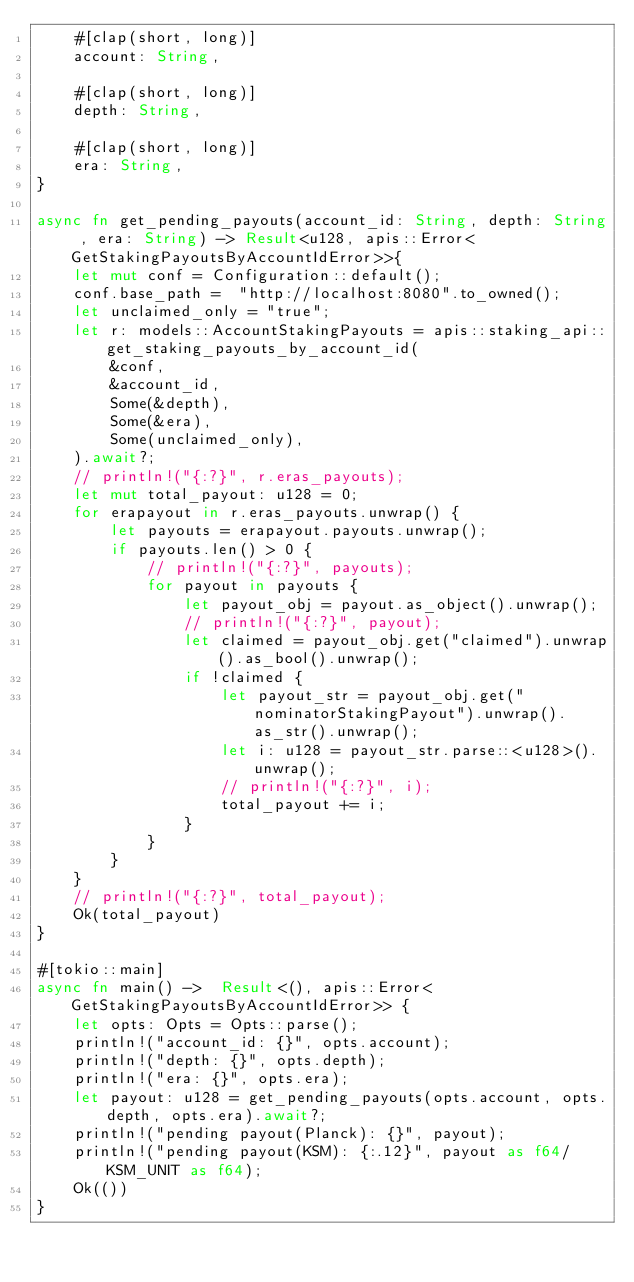Convert code to text. <code><loc_0><loc_0><loc_500><loc_500><_Rust_>    #[clap(short, long)]
    account: String,

    #[clap(short, long)]
    depth: String,

    #[clap(short, long)]
    era: String,
}

async fn get_pending_payouts(account_id: String, depth: String , era: String) -> Result<u128, apis::Error<GetStakingPayoutsByAccountIdError>>{
    let mut conf = Configuration::default();
    conf.base_path =  "http://localhost:8080".to_owned();
    let unclaimed_only = "true";
    let r: models::AccountStakingPayouts = apis::staking_api::get_staking_payouts_by_account_id(
        &conf,
        &account_id,
        Some(&depth),
        Some(&era),
        Some(unclaimed_only),
    ).await?;
    // println!("{:?}", r.eras_payouts);
    let mut total_payout: u128 = 0;
    for erapayout in r.eras_payouts.unwrap() {
        let payouts = erapayout.payouts.unwrap();
        if payouts.len() > 0 {
            // println!("{:?}", payouts);
            for payout in payouts {
                let payout_obj = payout.as_object().unwrap();
                // println!("{:?}", payout);
                let claimed = payout_obj.get("claimed").unwrap().as_bool().unwrap();
                if !claimed {
                    let payout_str = payout_obj.get("nominatorStakingPayout").unwrap().as_str().unwrap();
                    let i: u128 = payout_str.parse::<u128>().unwrap();
                    // println!("{:?}", i);
                    total_payout += i;                
                }
            }
        }
    }
    // println!("{:?}", total_payout);
    Ok(total_payout)
}

#[tokio::main]
async fn main() ->  Result<(), apis::Error<GetStakingPayoutsByAccountIdError>> {
    let opts: Opts = Opts::parse();
    println!("account_id: {}", opts.account);
    println!("depth: {}", opts.depth);
    println!("era: {}", opts.era);
    let payout: u128 = get_pending_payouts(opts.account, opts.depth, opts.era).await?;
    println!("pending payout(Planck): {}", payout);
    println!("pending payout(KSM): {:.12}", payout as f64/KSM_UNIT as f64);
    Ok(())
}
</code> 